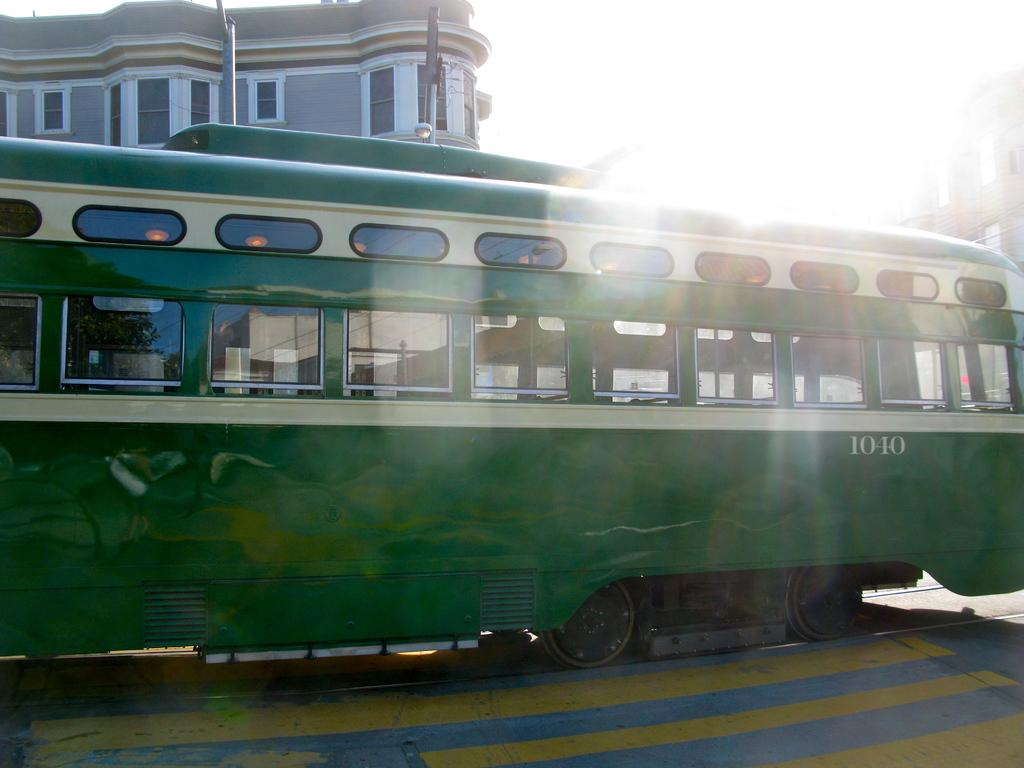<image>
Relay a brief, clear account of the picture shown. A green train is numbered 1040 and does not have any passengers. 